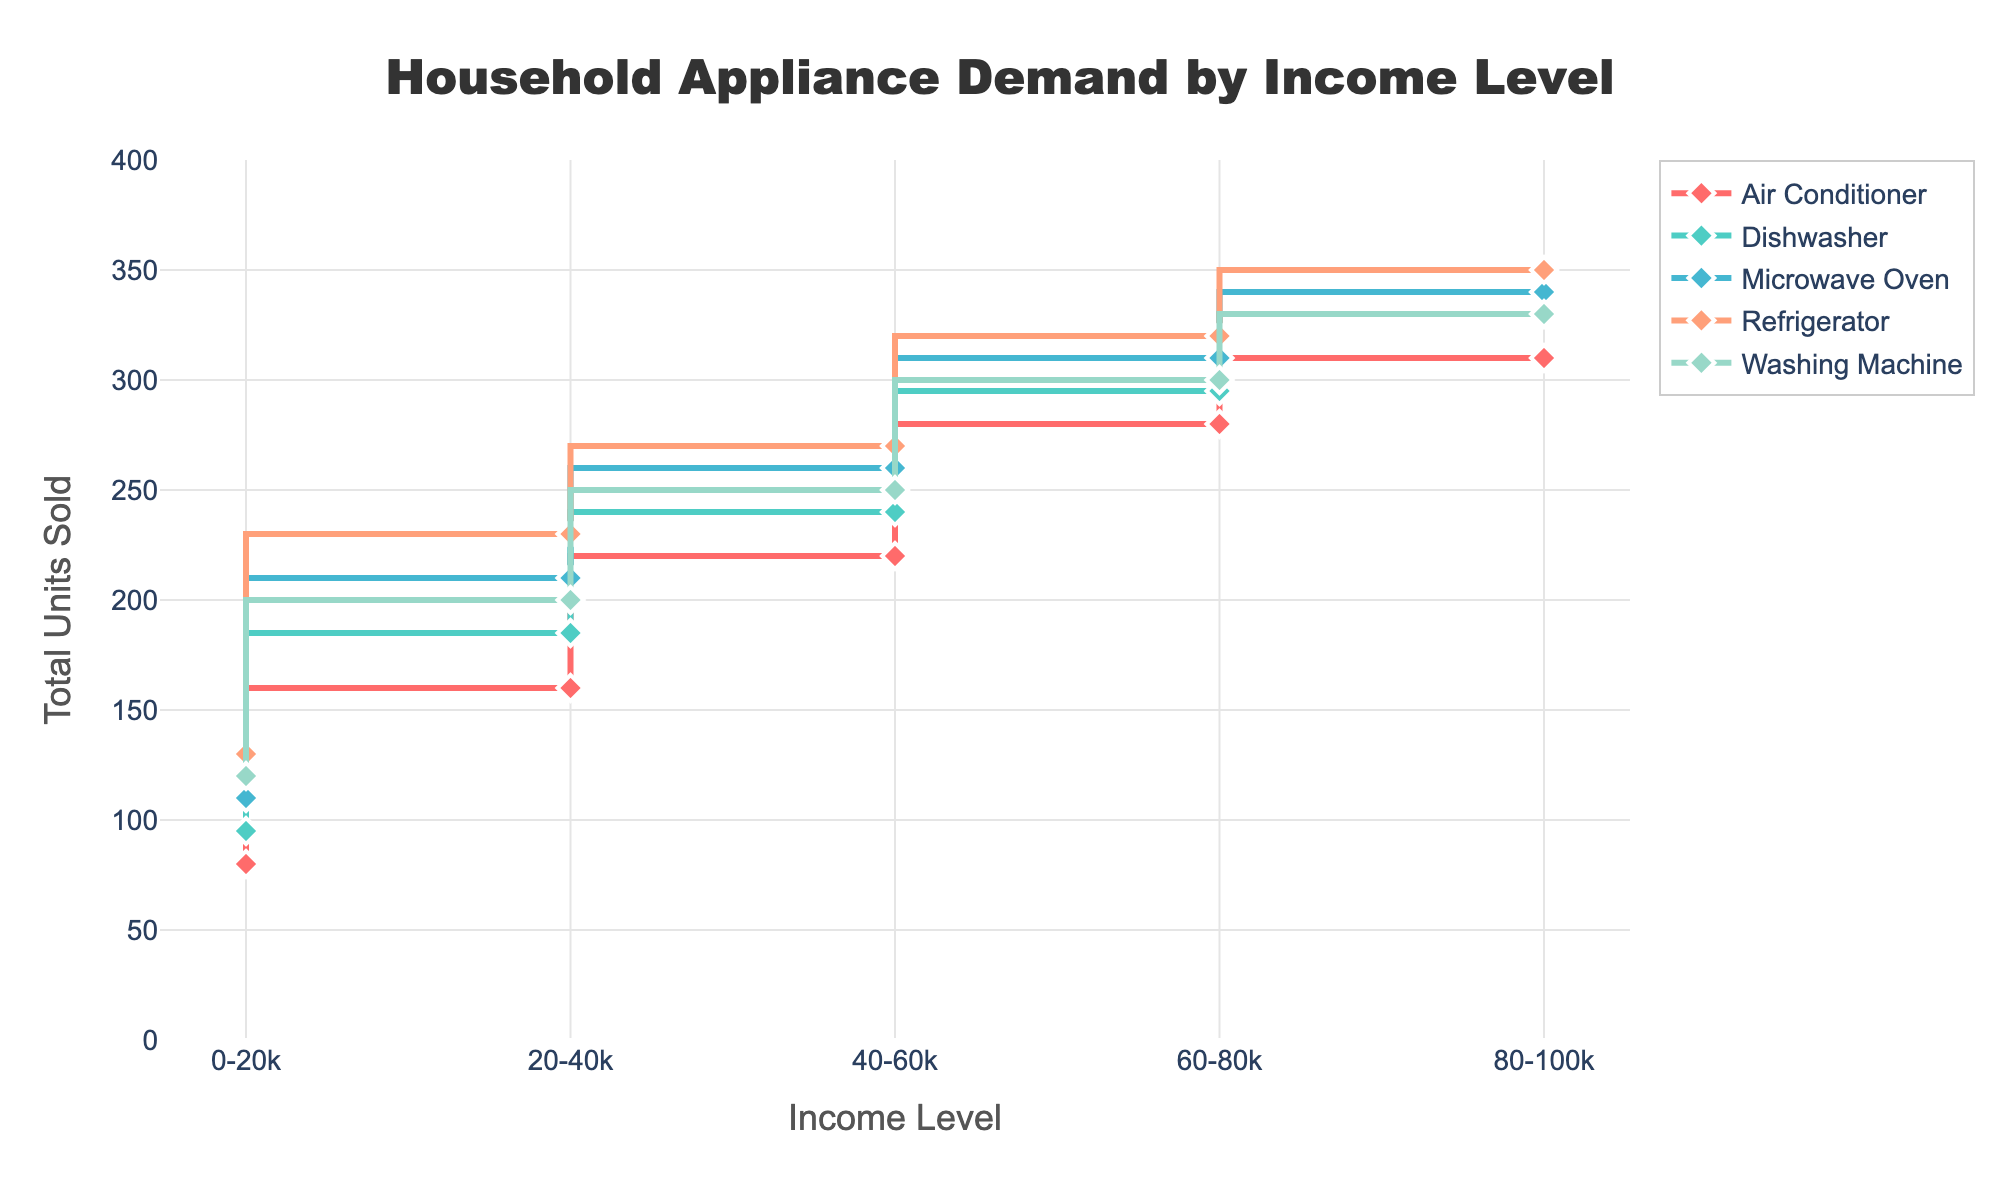what is the title of the plot? Look at the top of the plot to identify the text displayed as the title.
Answer: Household Appliance Demand by Income Level how many colors are used to represent different appliances on the plot? Observe the lines and markers in the plot, each representing a different appliance, and count the number of distinct colors used.
Answer: 5 which income level has the highest total units sold for Refrigerators? Inspect the plot and find the income level on the x-axis with the highest data point for Refrigerators.
Answer: 80-100k what is the total number of Washing Machines and Dishwashers sold in the 60-80k income level? Locate the points for Washing Machines and Dishwashers on the 60-80k income level on the x-axis and sum up their values (300 + 295).
Answer: 595 how much more are Air Conditioners sold in the 80-100k income level compared to the 0-20k income level? Compare the values of Air Conditioners for the 80-100k and 0-20k income levels on the plot and find the difference (310 - 80).
Answer: 230 which two income levels have the largest difference in Microwave Oven sales? Identify the highest and lowest data points for Microwave Ovens across all income levels and calculate their difference. The highest is at 80-100k (340) and the lowest at 0-20k (110), so the difference is 340 - 110.
Answer: 80-100k and 0-20k how does the sale of Dishwashers change as income levels increase from 0-20k to 80-100k? Track the changes in Dishwasher sales as the income levels progress from 0-20k to 80-100k, noting the trend. Dishwasher sales grow from 95 in the 0-20k level to 330 in the 80-100k level.
Answer: Increasing trend what is the average total units sold for Washing Machines across all income levels? Identify the total units sold for Washing Machines at each income level, sum them up and divide by the number of income levels (the sum of (120 + 200 + 250 + 300 + 330) divided by 5).
Answer: 240 which appliance shows the smallest increase in demand as income level rises? Compare the increases in data points across income levels for all appliances and determine which has the least change from 0-20k to 80-100k.
Answer: Dishwasher are there any income levels where the sales of two appliances are the same? If so, which appliances and income levels? Compare the data points of all appliances at each income level and identify if any two appliances have identical sales figures. No two appliances have exactly the same sales figures at any income level.
Answer: None 